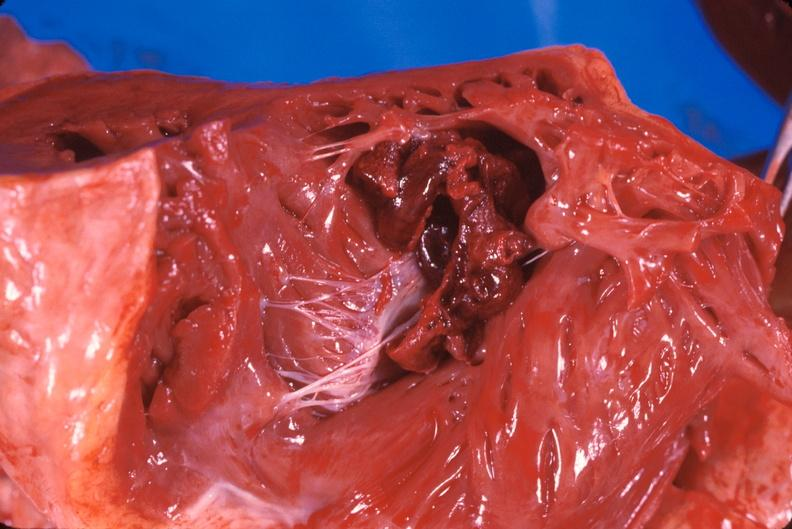what does this image show?
Answer the question using a single word or phrase. Thromboembolus from leg veins in right ventricle and atrium 